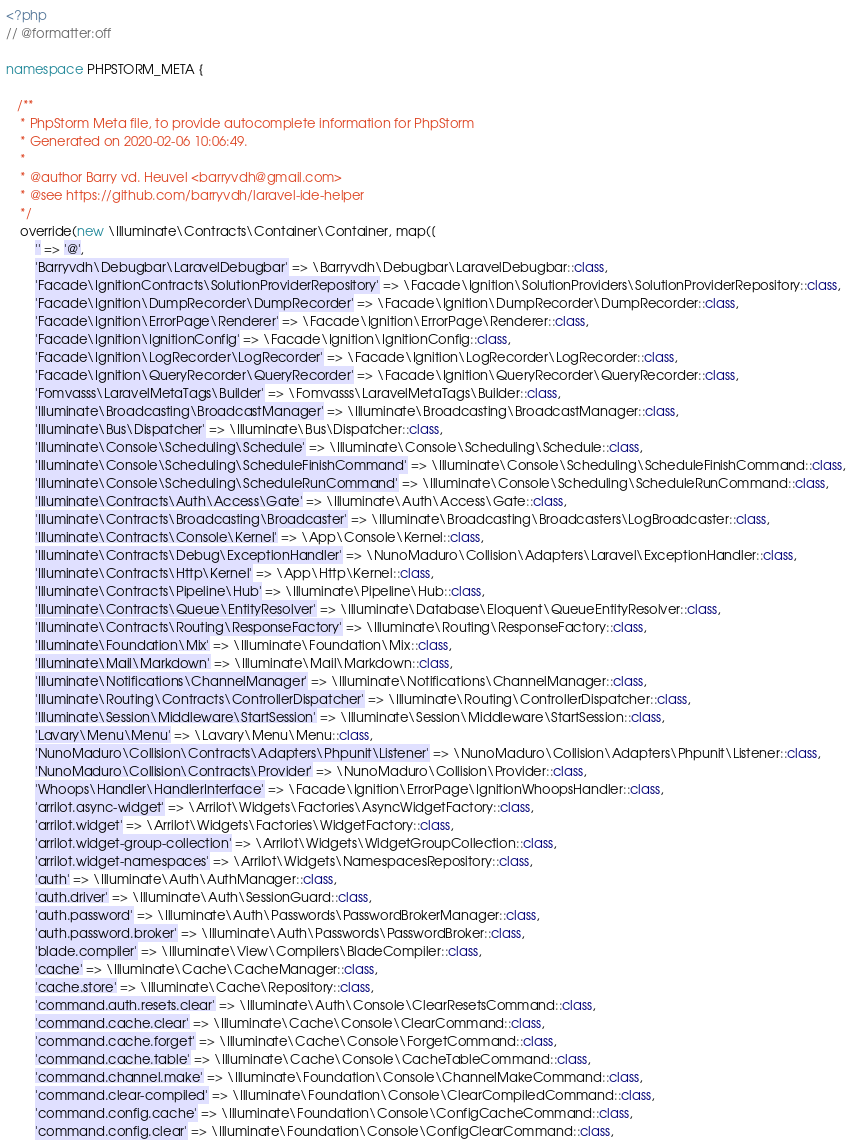Convert code to text. <code><loc_0><loc_0><loc_500><loc_500><_PHP_><?php
// @formatter:off

namespace PHPSTORM_META {

   /**
    * PhpStorm Meta file, to provide autocomplete information for PhpStorm
    * Generated on 2020-02-06 10:06:49.
    *
    * @author Barry vd. Heuvel <barryvdh@gmail.com>
    * @see https://github.com/barryvdh/laravel-ide-helper
    */
    override(new \Illuminate\Contracts\Container\Container, map([
        '' => '@',
        'Barryvdh\Debugbar\LaravelDebugbar' => \Barryvdh\Debugbar\LaravelDebugbar::class,
        'Facade\IgnitionContracts\SolutionProviderRepository' => \Facade\Ignition\SolutionProviders\SolutionProviderRepository::class,
        'Facade\Ignition\DumpRecorder\DumpRecorder' => \Facade\Ignition\DumpRecorder\DumpRecorder::class,
        'Facade\Ignition\ErrorPage\Renderer' => \Facade\Ignition\ErrorPage\Renderer::class,
        'Facade\Ignition\IgnitionConfig' => \Facade\Ignition\IgnitionConfig::class,
        'Facade\Ignition\LogRecorder\LogRecorder' => \Facade\Ignition\LogRecorder\LogRecorder::class,
        'Facade\Ignition\QueryRecorder\QueryRecorder' => \Facade\Ignition\QueryRecorder\QueryRecorder::class,
        'Fomvasss\LaravelMetaTags\Builder' => \Fomvasss\LaravelMetaTags\Builder::class,
        'Illuminate\Broadcasting\BroadcastManager' => \Illuminate\Broadcasting\BroadcastManager::class,
        'Illuminate\Bus\Dispatcher' => \Illuminate\Bus\Dispatcher::class,
        'Illuminate\Console\Scheduling\Schedule' => \Illuminate\Console\Scheduling\Schedule::class,
        'Illuminate\Console\Scheduling\ScheduleFinishCommand' => \Illuminate\Console\Scheduling\ScheduleFinishCommand::class,
        'Illuminate\Console\Scheduling\ScheduleRunCommand' => \Illuminate\Console\Scheduling\ScheduleRunCommand::class,
        'Illuminate\Contracts\Auth\Access\Gate' => \Illuminate\Auth\Access\Gate::class,
        'Illuminate\Contracts\Broadcasting\Broadcaster' => \Illuminate\Broadcasting\Broadcasters\LogBroadcaster::class,
        'Illuminate\Contracts\Console\Kernel' => \App\Console\Kernel::class,
        'Illuminate\Contracts\Debug\ExceptionHandler' => \NunoMaduro\Collision\Adapters\Laravel\ExceptionHandler::class,
        'Illuminate\Contracts\Http\Kernel' => \App\Http\Kernel::class,
        'Illuminate\Contracts\Pipeline\Hub' => \Illuminate\Pipeline\Hub::class,
        'Illuminate\Contracts\Queue\EntityResolver' => \Illuminate\Database\Eloquent\QueueEntityResolver::class,
        'Illuminate\Contracts\Routing\ResponseFactory' => \Illuminate\Routing\ResponseFactory::class,
        'Illuminate\Foundation\Mix' => \Illuminate\Foundation\Mix::class,
        'Illuminate\Mail\Markdown' => \Illuminate\Mail\Markdown::class,
        'Illuminate\Notifications\ChannelManager' => \Illuminate\Notifications\ChannelManager::class,
        'Illuminate\Routing\Contracts\ControllerDispatcher' => \Illuminate\Routing\ControllerDispatcher::class,
        'Illuminate\Session\Middleware\StartSession' => \Illuminate\Session\Middleware\StartSession::class,
        'Lavary\Menu\Menu' => \Lavary\Menu\Menu::class,
        'NunoMaduro\Collision\Contracts\Adapters\Phpunit\Listener' => \NunoMaduro\Collision\Adapters\Phpunit\Listener::class,
        'NunoMaduro\Collision\Contracts\Provider' => \NunoMaduro\Collision\Provider::class,
        'Whoops\Handler\HandlerInterface' => \Facade\Ignition\ErrorPage\IgnitionWhoopsHandler::class,
        'arrilot.async-widget' => \Arrilot\Widgets\Factories\AsyncWidgetFactory::class,
        'arrilot.widget' => \Arrilot\Widgets\Factories\WidgetFactory::class,
        'arrilot.widget-group-collection' => \Arrilot\Widgets\WidgetGroupCollection::class,
        'arrilot.widget-namespaces' => \Arrilot\Widgets\NamespacesRepository::class,
        'auth' => \Illuminate\Auth\AuthManager::class,
        'auth.driver' => \Illuminate\Auth\SessionGuard::class,
        'auth.password' => \Illuminate\Auth\Passwords\PasswordBrokerManager::class,
        'auth.password.broker' => \Illuminate\Auth\Passwords\PasswordBroker::class,
        'blade.compiler' => \Illuminate\View\Compilers\BladeCompiler::class,
        'cache' => \Illuminate\Cache\CacheManager::class,
        'cache.store' => \Illuminate\Cache\Repository::class,
        'command.auth.resets.clear' => \Illuminate\Auth\Console\ClearResetsCommand::class,
        'command.cache.clear' => \Illuminate\Cache\Console\ClearCommand::class,
        'command.cache.forget' => \Illuminate\Cache\Console\ForgetCommand::class,
        'command.cache.table' => \Illuminate\Cache\Console\CacheTableCommand::class,
        'command.channel.make' => \Illuminate\Foundation\Console\ChannelMakeCommand::class,
        'command.clear-compiled' => \Illuminate\Foundation\Console\ClearCompiledCommand::class,
        'command.config.cache' => \Illuminate\Foundation\Console\ConfigCacheCommand::class,
        'command.config.clear' => \Illuminate\Foundation\Console\ConfigClearCommand::class,</code> 